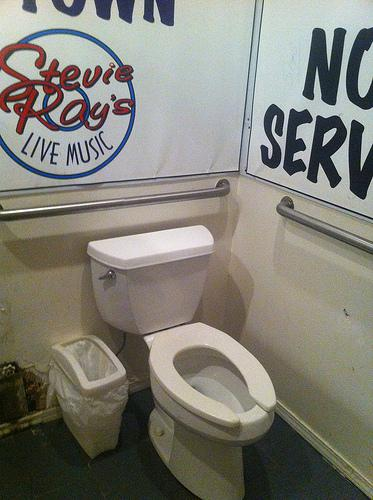Question: what is the focus?
Choices:
A. Sink.
B. Toilet.
C. Floor drain.
D. Window.
Answer with the letter. Answer: B Question: where is this shot?
Choices:
A. Cubical.
B. Closet.
C. Stall.
D. Bedroom.
Answer with the letter. Answer: C Question: what does the circle say?
Choices:
A. Fine dining.
B. Stevie ray's live music.
C. No shirt, no shoes, no service.
D. Cash and credit cards accepted.
Answer with the letter. Answer: B Question: what are the metal poles for?
Choices:
A. Structural support.
B. Handrails.
C. Practicing ballet.
D. Tying up horses.
Answer with the letter. Answer: B Question: what color is the walls below the poles?
Choices:
A. White.
B. Beige.
C. Yellow.
D. Blue.
Answer with the letter. Answer: B 